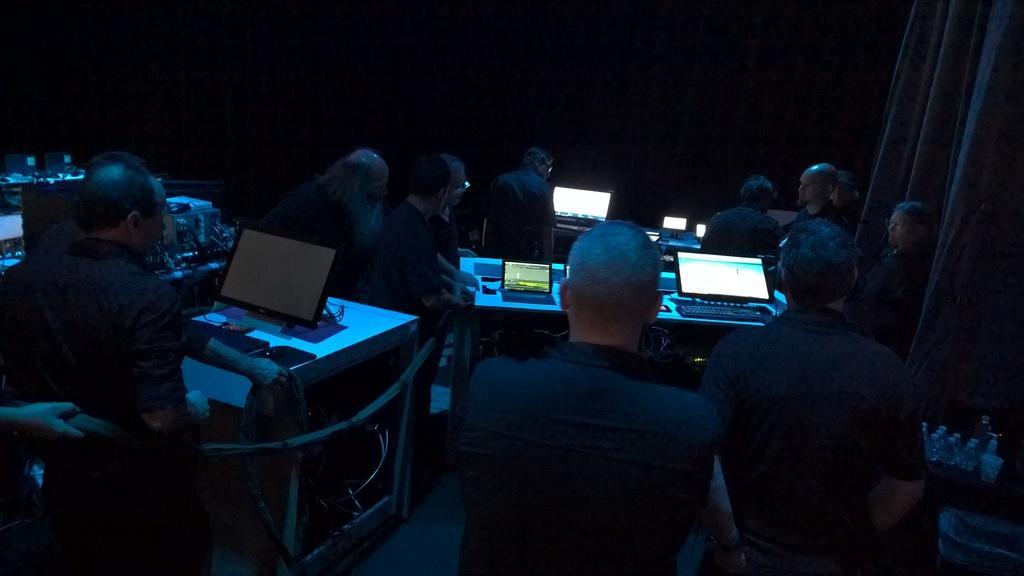Could you give a brief overview of what you see in this image? In this image I can see people sitting. There are laptops on the tables. There are curtains at the right back and there is dark at the back. 